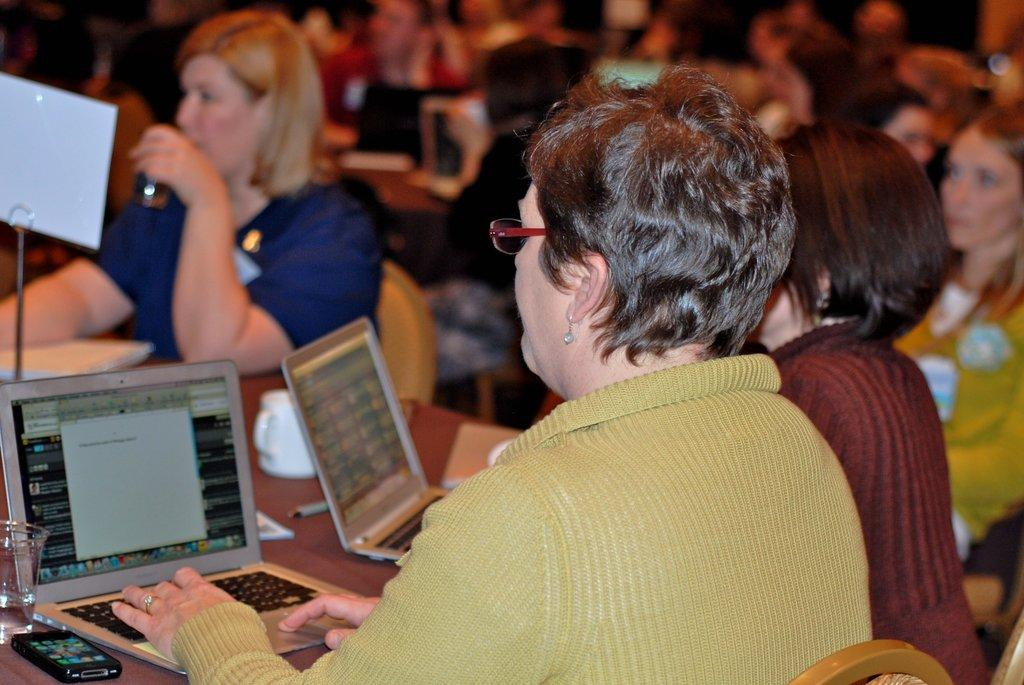How many people are in the image? There is a group of people in the image. What are the people doing in the image? The people are sitting on chairs. What electronic devices can be seen in the image? There are laptops in the image. What type of containers are present in the image? There is a cup and a glass in the image. What other object can be seen in the image? There is a mobile and a pen in the image. Can you describe the background of the image? The background of the image is blurry. What type of operation is being performed on the airplane in the image? There is no airplane present in the image, so no operation can be observed. What type of paste is being used by the people in the image? There is no paste present in the image, and no activity involving paste can be observed. 